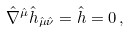<formula> <loc_0><loc_0><loc_500><loc_500>\hat { \nabla } ^ { \hat { \mu } } \hat { h } _ { \hat { \mu } \hat { \nu } } = \hat { h } = 0 \, ,</formula> 